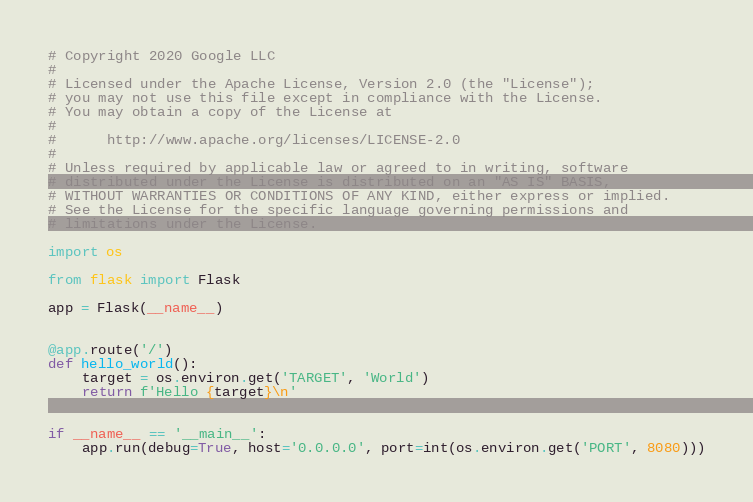Convert code to text. <code><loc_0><loc_0><loc_500><loc_500><_Python_># Copyright 2020 Google LLC
#
# Licensed under the Apache License, Version 2.0 (the "License");
# you may not use this file except in compliance with the License.
# You may obtain a copy of the License at
#
#      http://www.apache.org/licenses/LICENSE-2.0
#
# Unless required by applicable law or agreed to in writing, software
# distributed under the License is distributed on an "AS IS" BASIS,
# WITHOUT WARRANTIES OR CONDITIONS OF ANY KIND, either express or implied.
# See the License for the specific language governing permissions and
# limitations under the License.

import os

from flask import Flask

app = Flask(__name__)


@app.route('/')
def hello_world():
    target = os.environ.get('TARGET', 'World')
    return f'Hello {target}\n'


if __name__ == '__main__':
    app.run(debug=True, host='0.0.0.0', port=int(os.environ.get('PORT', 8080)))
</code> 